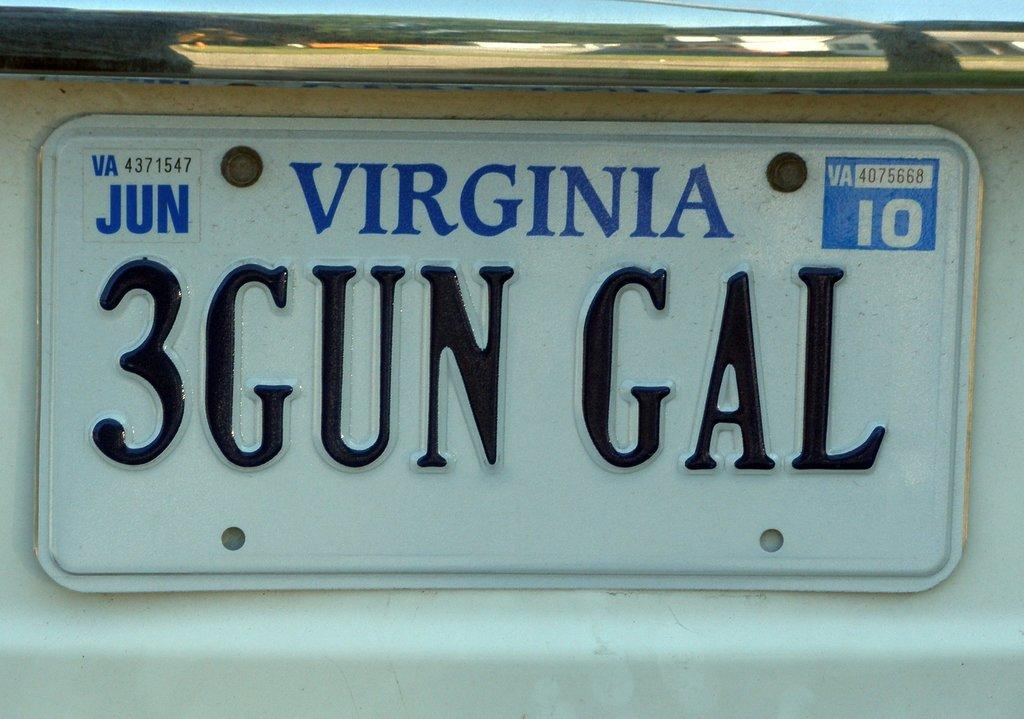<image>
Render a clear and concise summary of the photo. a close up of a Virginia license plate 3Gun Gal 